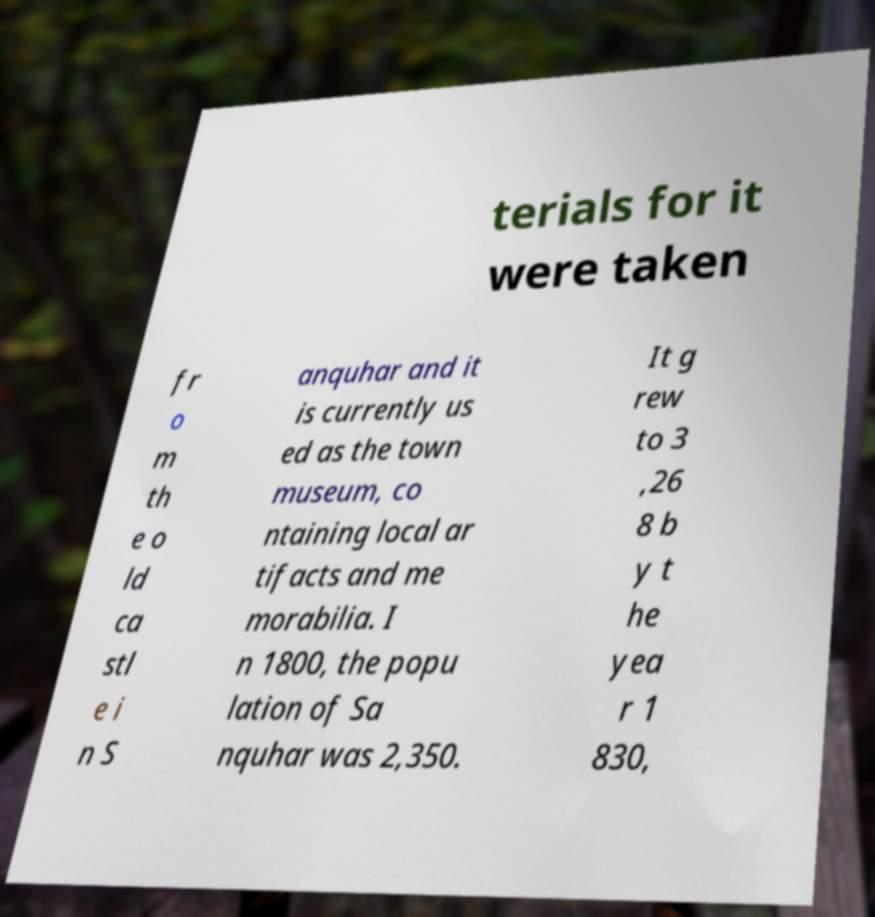What messages or text are displayed in this image? I need them in a readable, typed format. terials for it were taken fr o m th e o ld ca stl e i n S anquhar and it is currently us ed as the town museum, co ntaining local ar tifacts and me morabilia. I n 1800, the popu lation of Sa nquhar was 2,350. It g rew to 3 ,26 8 b y t he yea r 1 830, 